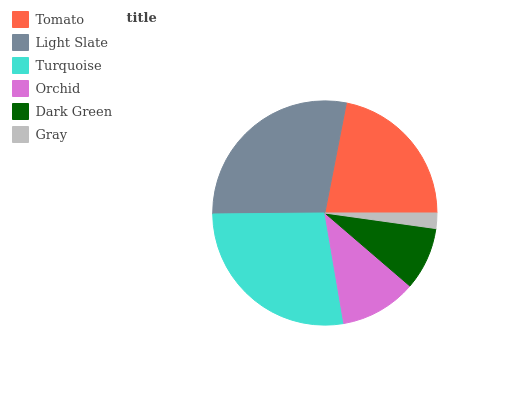Is Gray the minimum?
Answer yes or no. Yes. Is Light Slate the maximum?
Answer yes or no. Yes. Is Turquoise the minimum?
Answer yes or no. No. Is Turquoise the maximum?
Answer yes or no. No. Is Light Slate greater than Turquoise?
Answer yes or no. Yes. Is Turquoise less than Light Slate?
Answer yes or no. Yes. Is Turquoise greater than Light Slate?
Answer yes or no. No. Is Light Slate less than Turquoise?
Answer yes or no. No. Is Tomato the high median?
Answer yes or no. Yes. Is Orchid the low median?
Answer yes or no. Yes. Is Gray the high median?
Answer yes or no. No. Is Dark Green the low median?
Answer yes or no. No. 